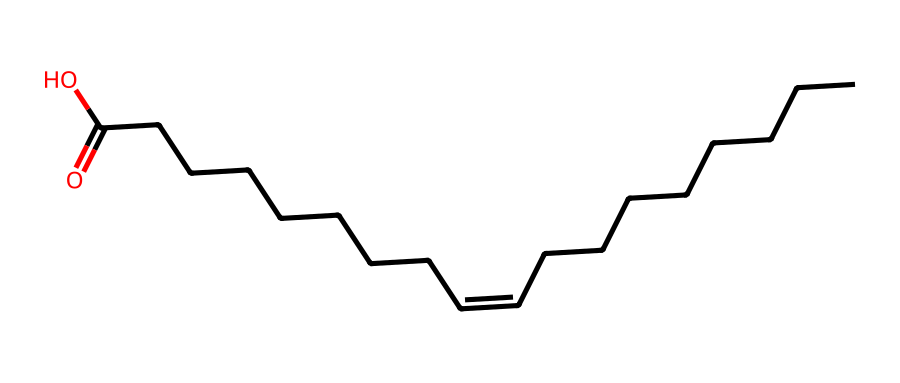What type of fatty acid is represented by this chemical structure? The chemical structure includes a double bond between carbon atoms in a long carbon chain, which indicates that it is an unsaturated fatty acid.
Answer: unsaturated fatty acid How many carbon atoms are in this fatty acid? By counting the carbon atoms in the chain, there are a total of 18 carbon atoms present.
Answer: 18 What is the configuration type of the double bond in this chemical? The double bond is represented as "/C=C\", indicating that it has a trans configuration due to the notation used for the arrangement of substituents.
Answer: trans Does this fatty acid contain a carboxylic acid functional group? The ending "C(=O)O" in the structure indicates a carboxylic acid functional group is present in the molecule.
Answer: yes What effect does the trans configuration have on the physical properties of the fatty acid? The trans configuration typically results in a straighter chain structure, which allows the fatty acids to pack more closely together, generally leading to higher melting points.
Answer: higher melting point Can this fatty acid be found in industrial fats or oils? The presence of trans configuration suggests that this fatty acid can be commonly found in partially hydrogenated oils used in various processed foods.
Answer: yes 